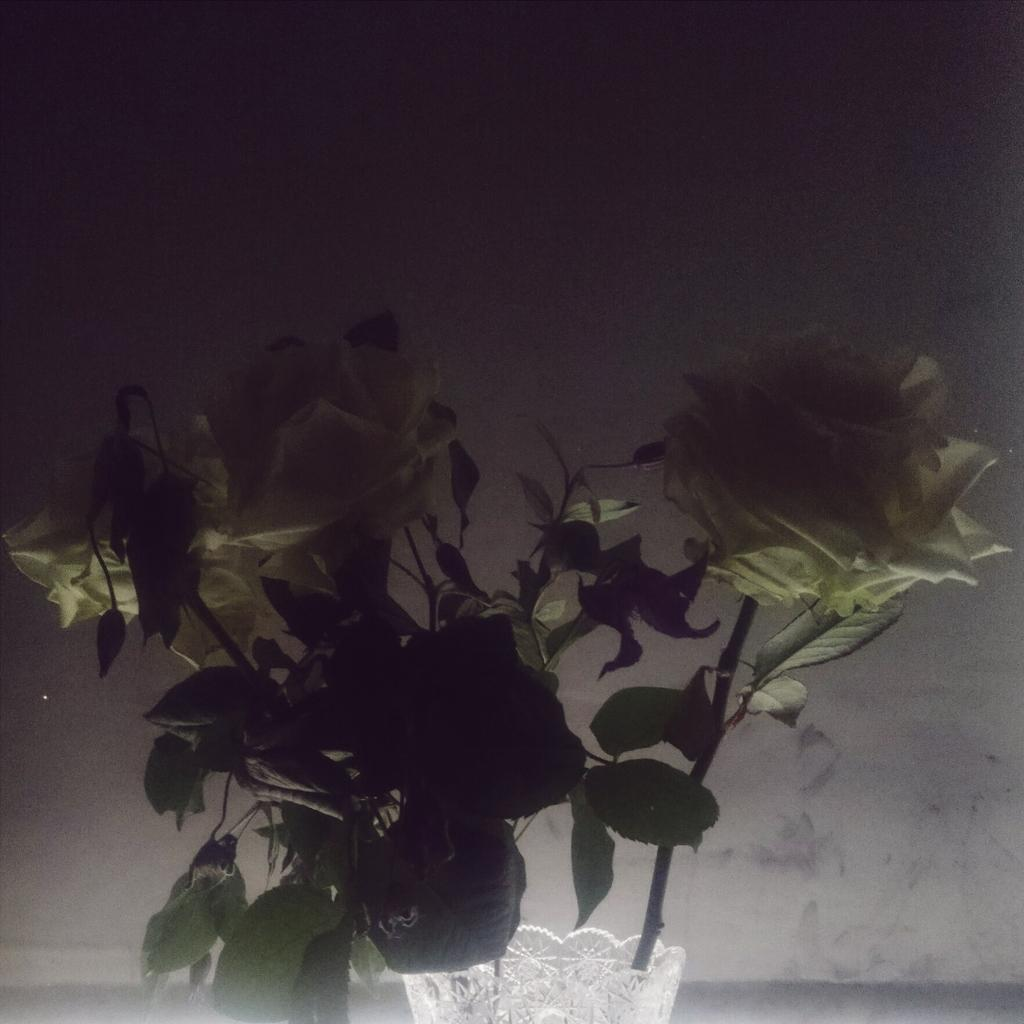What type of living organisms can be seen in the image? There are flowers in the image. Where are the flowers located? The flowers are on a plant. What is visible in the background of the image? There is a wall in the background of the image. What type of pest can be seen crawling on the flowers in the image? There is no pest visible on the flowers in the image. What type of writing can be seen on the flowers in the image? There is no writing present on the flowers in the image. 